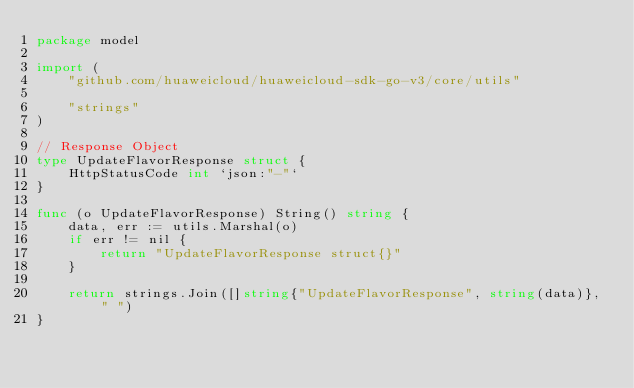<code> <loc_0><loc_0><loc_500><loc_500><_Go_>package model

import (
	"github.com/huaweicloud/huaweicloud-sdk-go-v3/core/utils"

	"strings"
)

// Response Object
type UpdateFlavorResponse struct {
	HttpStatusCode int `json:"-"`
}

func (o UpdateFlavorResponse) String() string {
	data, err := utils.Marshal(o)
	if err != nil {
		return "UpdateFlavorResponse struct{}"
	}

	return strings.Join([]string{"UpdateFlavorResponse", string(data)}, " ")
}
</code> 